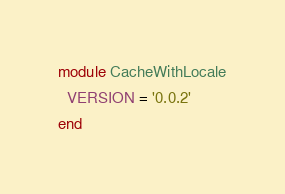<code> <loc_0><loc_0><loc_500><loc_500><_Ruby_>module CacheWithLocale
  VERSION = '0.0.2'
end
</code> 